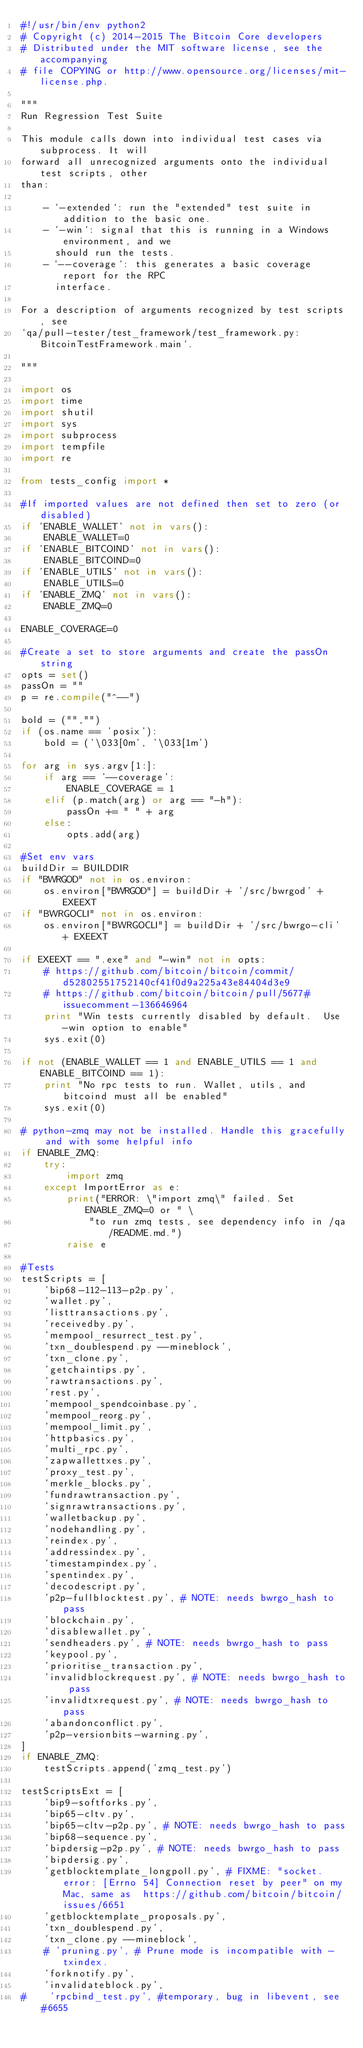Convert code to text. <code><loc_0><loc_0><loc_500><loc_500><_Python_>#!/usr/bin/env python2
# Copyright (c) 2014-2015 The Bitcoin Core developers
# Distributed under the MIT software license, see the accompanying
# file COPYING or http://www.opensource.org/licenses/mit-license.php.

"""
Run Regression Test Suite

This module calls down into individual test cases via subprocess. It will
forward all unrecognized arguments onto the individual test scripts, other
than:

    - `-extended`: run the "extended" test suite in addition to the basic one.
    - `-win`: signal that this is running in a Windows environment, and we
      should run the tests.
    - `--coverage`: this generates a basic coverage report for the RPC
      interface.

For a description of arguments recognized by test scripts, see
`qa/pull-tester/test_framework/test_framework.py:BitcoinTestFramework.main`.

"""

import os
import time
import shutil
import sys
import subprocess
import tempfile
import re

from tests_config import *

#If imported values are not defined then set to zero (or disabled)
if 'ENABLE_WALLET' not in vars():
    ENABLE_WALLET=0
if 'ENABLE_BITCOIND' not in vars():
    ENABLE_BITCOIND=0
if 'ENABLE_UTILS' not in vars():
    ENABLE_UTILS=0
if 'ENABLE_ZMQ' not in vars():
    ENABLE_ZMQ=0

ENABLE_COVERAGE=0

#Create a set to store arguments and create the passOn string
opts = set()
passOn = ""
p = re.compile("^--")

bold = ("","")
if (os.name == 'posix'):
    bold = ('\033[0m', '\033[1m')

for arg in sys.argv[1:]:
    if arg == '--coverage':
        ENABLE_COVERAGE = 1
    elif (p.match(arg) or arg == "-h"):
        passOn += " " + arg
    else:
        opts.add(arg)

#Set env vars
buildDir = BUILDDIR
if "BWRGOD" not in os.environ:
    os.environ["BWRGOD"] = buildDir + '/src/bwrgod' + EXEEXT
if "BWRGOCLI" not in os.environ:
    os.environ["BWRGOCLI"] = buildDir + '/src/bwrgo-cli' + EXEEXT

if EXEEXT == ".exe" and "-win" not in opts:
    # https://github.com/bitcoin/bitcoin/commit/d52802551752140cf41f0d9a225a43e84404d3e9
    # https://github.com/bitcoin/bitcoin/pull/5677#issuecomment-136646964
    print "Win tests currently disabled by default.  Use -win option to enable"
    sys.exit(0)

if not (ENABLE_WALLET == 1 and ENABLE_UTILS == 1 and ENABLE_BITCOIND == 1):
    print "No rpc tests to run. Wallet, utils, and bitcoind must all be enabled"
    sys.exit(0)

# python-zmq may not be installed. Handle this gracefully and with some helpful info
if ENABLE_ZMQ:
    try:
        import zmq
    except ImportError as e:
        print("ERROR: \"import zmq\" failed. Set ENABLE_ZMQ=0 or " \
            "to run zmq tests, see dependency info in /qa/README.md.")
        raise e

#Tests
testScripts = [
    'bip68-112-113-p2p.py',
    'wallet.py',
    'listtransactions.py',
    'receivedby.py',
    'mempool_resurrect_test.py',
    'txn_doublespend.py --mineblock',
    'txn_clone.py',
    'getchaintips.py',
    'rawtransactions.py',
    'rest.py',
    'mempool_spendcoinbase.py',
    'mempool_reorg.py',
    'mempool_limit.py',
    'httpbasics.py',
    'multi_rpc.py',
    'zapwallettxes.py',
    'proxy_test.py',
    'merkle_blocks.py',
    'fundrawtransaction.py',
    'signrawtransactions.py',
    'walletbackup.py',
    'nodehandling.py',
    'reindex.py',
    'addressindex.py',
    'timestampindex.py',
    'spentindex.py',
    'decodescript.py',
    'p2p-fullblocktest.py', # NOTE: needs bwrgo_hash to pass
    'blockchain.py',
    'disablewallet.py',
    'sendheaders.py', # NOTE: needs bwrgo_hash to pass
    'keypool.py',
    'prioritise_transaction.py',
    'invalidblockrequest.py', # NOTE: needs bwrgo_hash to pass
    'invalidtxrequest.py', # NOTE: needs bwrgo_hash to pass
    'abandonconflict.py',
    'p2p-versionbits-warning.py',
]
if ENABLE_ZMQ:
    testScripts.append('zmq_test.py')

testScriptsExt = [
    'bip9-softforks.py',
    'bip65-cltv.py',
    'bip65-cltv-p2p.py', # NOTE: needs bwrgo_hash to pass
    'bip68-sequence.py',
    'bipdersig-p2p.py', # NOTE: needs bwrgo_hash to pass
    'bipdersig.py',
    'getblocktemplate_longpoll.py', # FIXME: "socket.error: [Errno 54] Connection reset by peer" on my Mac, same as  https://github.com/bitcoin/bitcoin/issues/6651
    'getblocktemplate_proposals.py',
    'txn_doublespend.py',
    'txn_clone.py --mineblock',
    # 'pruning.py', # Prune mode is incompatible with -txindex.
    'forknotify.py',
    'invalidateblock.py',
#    'rpcbind_test.py', #temporary, bug in libevent, see #6655</code> 